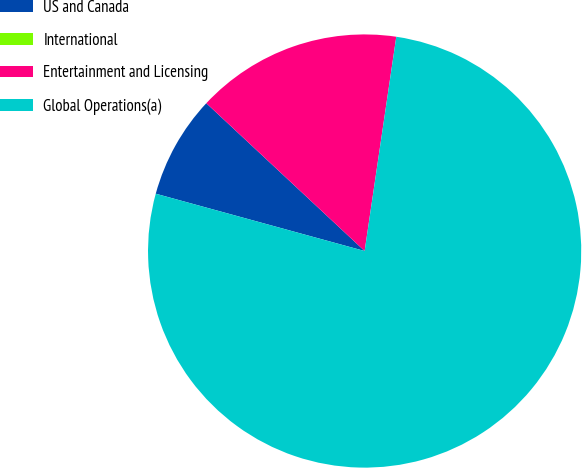Convert chart. <chart><loc_0><loc_0><loc_500><loc_500><pie_chart><fcel>US and Canada<fcel>International<fcel>Entertainment and Licensing<fcel>Global Operations(a)<nl><fcel>7.69%<fcel>0.0%<fcel>15.38%<fcel>76.92%<nl></chart> 